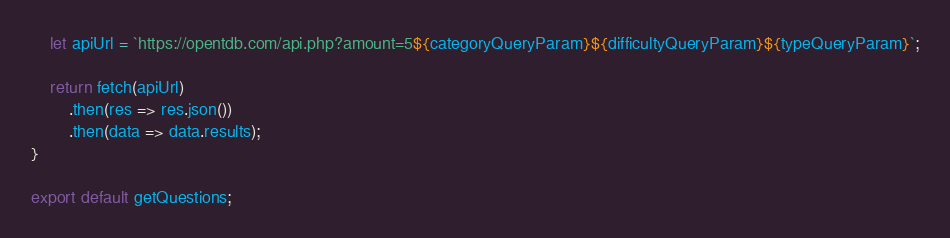Convert code to text. <code><loc_0><loc_0><loc_500><loc_500><_JavaScript_>
	let apiUrl = `https://opentdb.com/api.php?amount=5${categoryQueryParam}${difficultyQueryParam}${typeQueryParam}`;

	return fetch(apiUrl)
		.then(res => res.json())
		.then(data => data.results);
}

export default getQuestions;</code> 